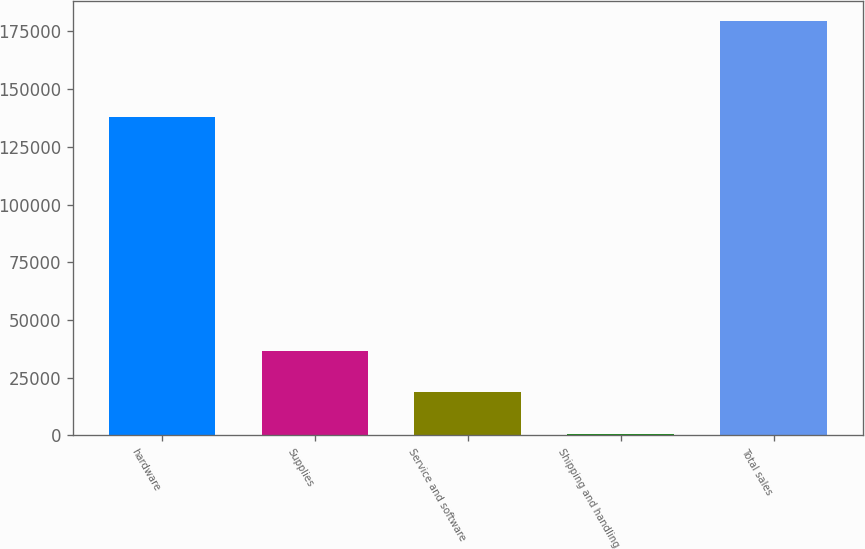Convert chart to OTSL. <chart><loc_0><loc_0><loc_500><loc_500><bar_chart><fcel>hardware<fcel>Supplies<fcel>Service and software<fcel>Shipping and handling<fcel>Total sales<nl><fcel>137803<fcel>36525.2<fcel>18679.1<fcel>833<fcel>179294<nl></chart> 